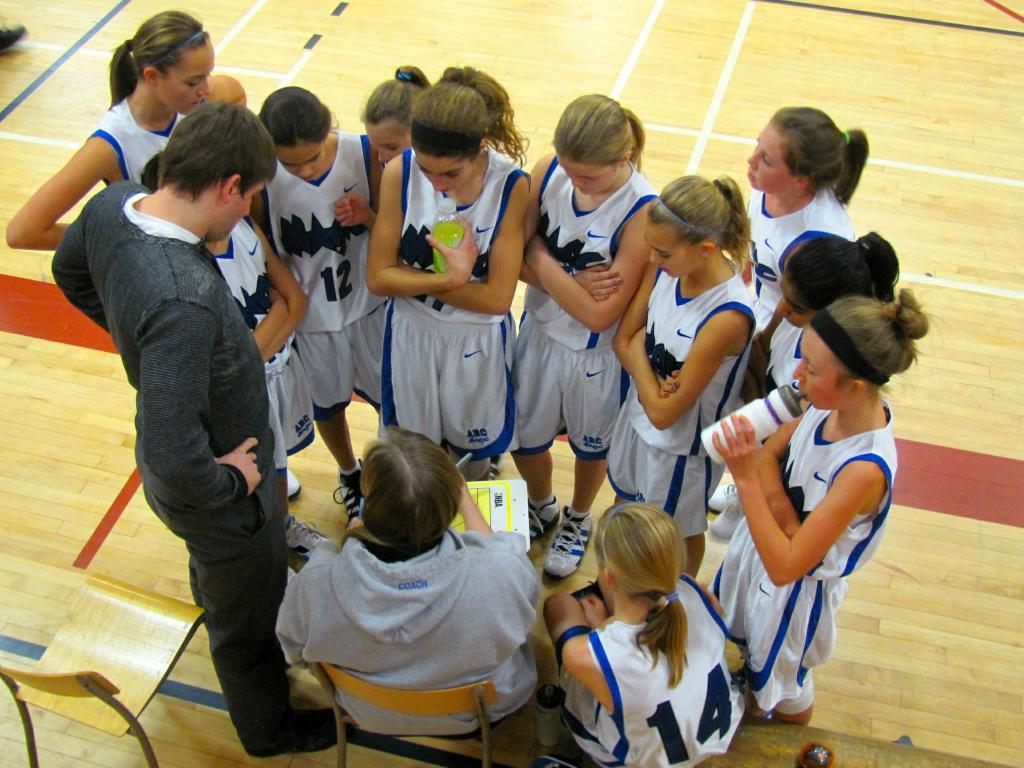<image>
Create a compact narrative representing the image presented. A girl in a number 14 basketball jersey sits in a huddle. 